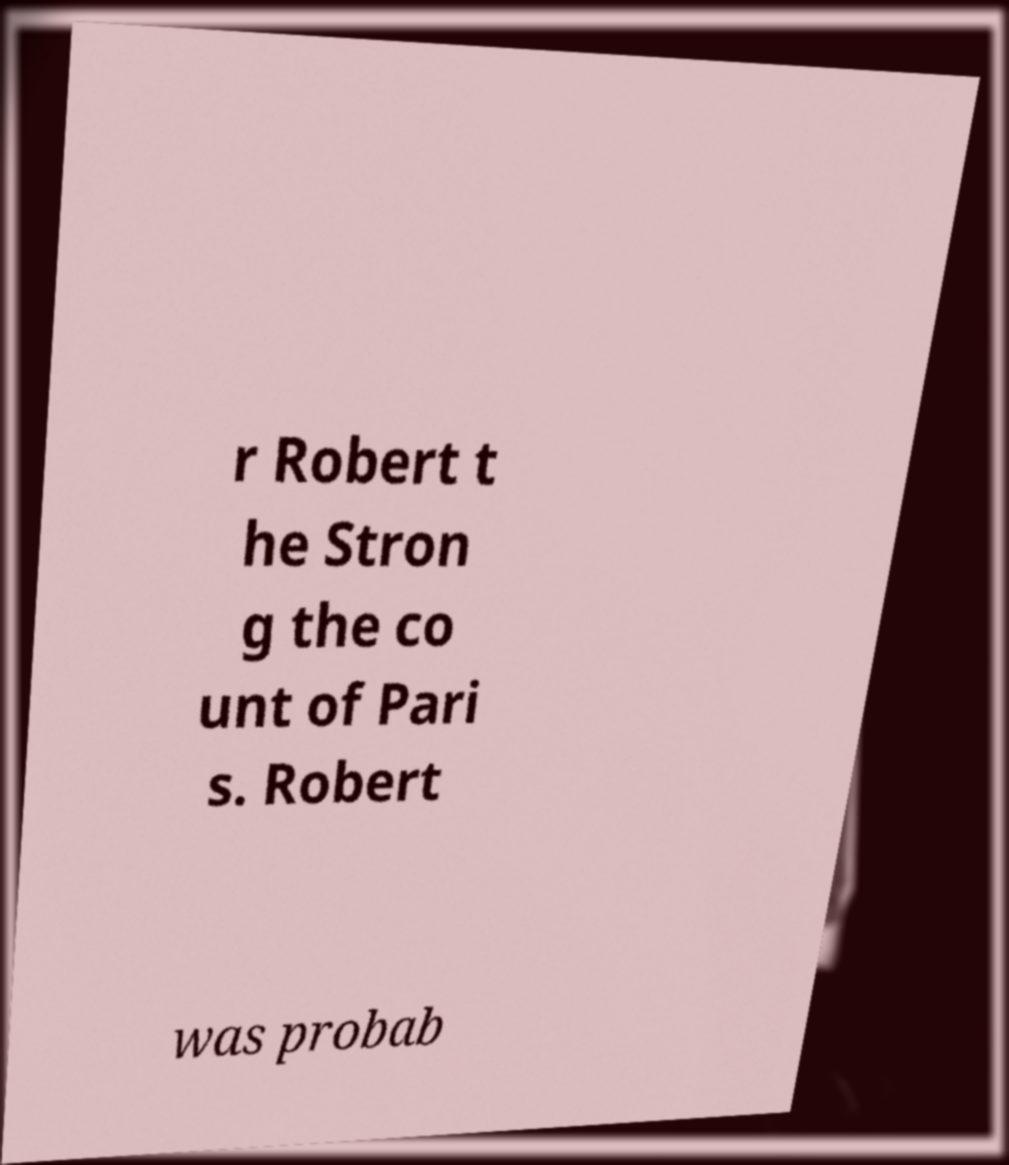Can you read and provide the text displayed in the image?This photo seems to have some interesting text. Can you extract and type it out for me? r Robert t he Stron g the co unt of Pari s. Robert was probab 